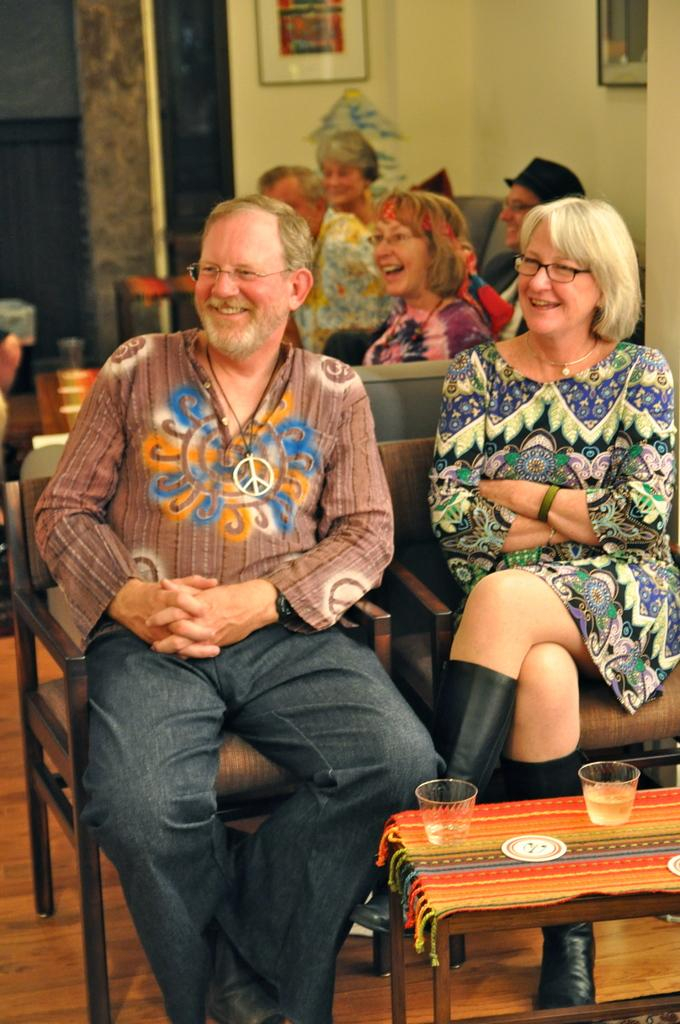What is happening in the image? There is a group of people in the image, and they are seated on chairs. What objects are present on the table in the image? There are two cups on a table in the image. How much was the payment for the bed in the image? There is no bed or payment mentioned in the image; it only shows a group of people seated on chairs and two cups on a table. 